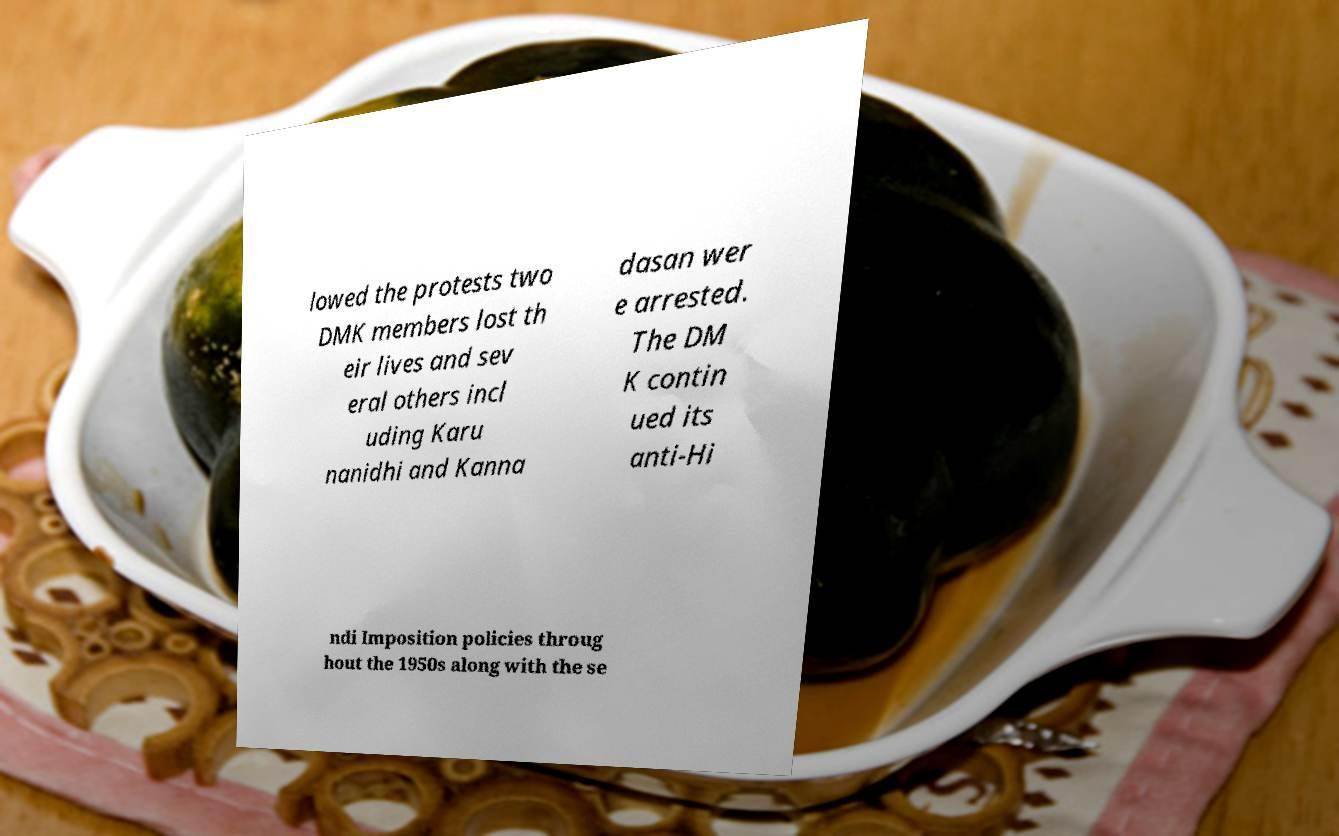Can you accurately transcribe the text from the provided image for me? lowed the protests two DMK members lost th eir lives and sev eral others incl uding Karu nanidhi and Kanna dasan wer e arrested. The DM K contin ued its anti-Hi ndi Imposition policies throug hout the 1950s along with the se 